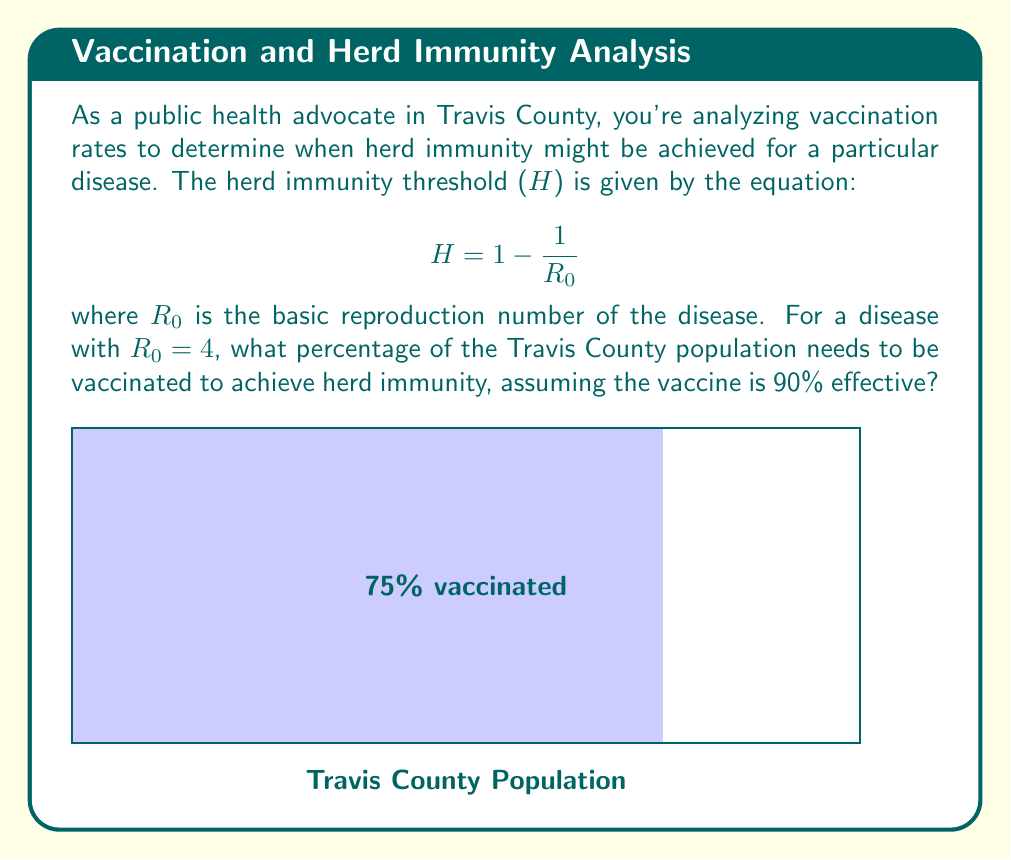Solve this math problem. Let's approach this step-by-step:

1) First, we calculate the herd immunity threshold (H) using the given equation:

   $$H = 1 - \frac{1}{R_0} = 1 - \frac{1}{4} = 0.75 = 75\%$$

2) This means that 75% of the population needs to be immune to achieve herd immunity.

3) However, the vaccine is not 100% effective. It's only 90% effective. We need to account for this in our calculations.

4) Let x be the proportion of the population that needs to be vaccinated. Then:

   $0.90x = 0.75$

   This equation states that 90% of the vaccinated proportion should equal the 75% immunity needed.

5) Solving for x:

   $$x = \frac{0.75}{0.90} = \frac{5}{6} \approx 0.8333$$

6) Convert to a percentage:

   $0.8333 * 100\% = 83.33\%$

Therefore, approximately 83.33% of the Travis County population needs to be vaccinated to achieve herd immunity.
Answer: 83.33% 